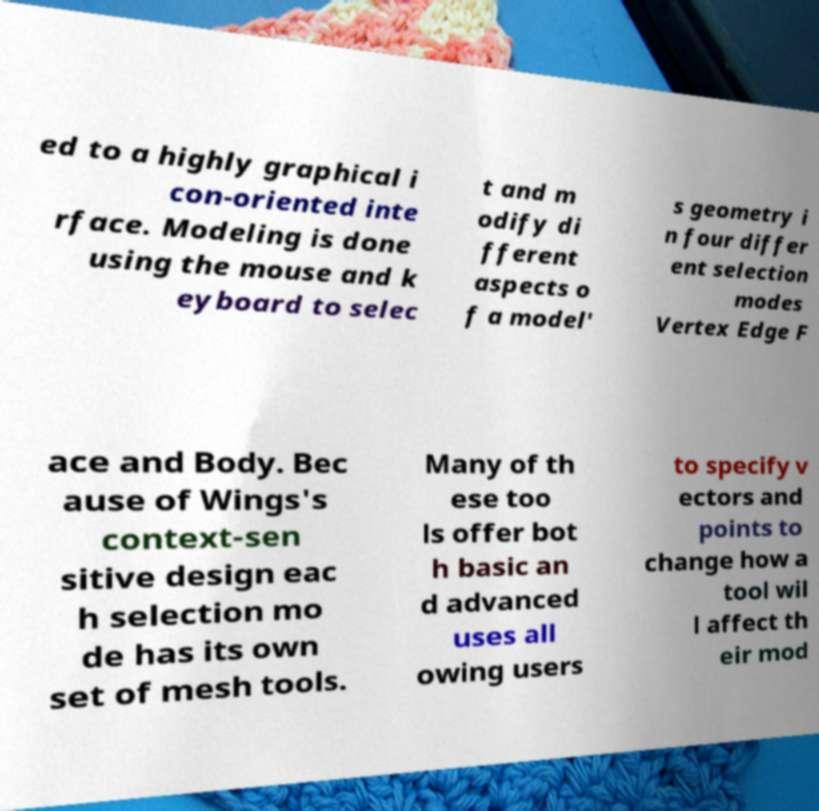Can you accurately transcribe the text from the provided image for me? ed to a highly graphical i con-oriented inte rface. Modeling is done using the mouse and k eyboard to selec t and m odify di fferent aspects o f a model' s geometry i n four differ ent selection modes Vertex Edge F ace and Body. Bec ause of Wings's context-sen sitive design eac h selection mo de has its own set of mesh tools. Many of th ese too ls offer bot h basic an d advanced uses all owing users to specify v ectors and points to change how a tool wil l affect th eir mod 